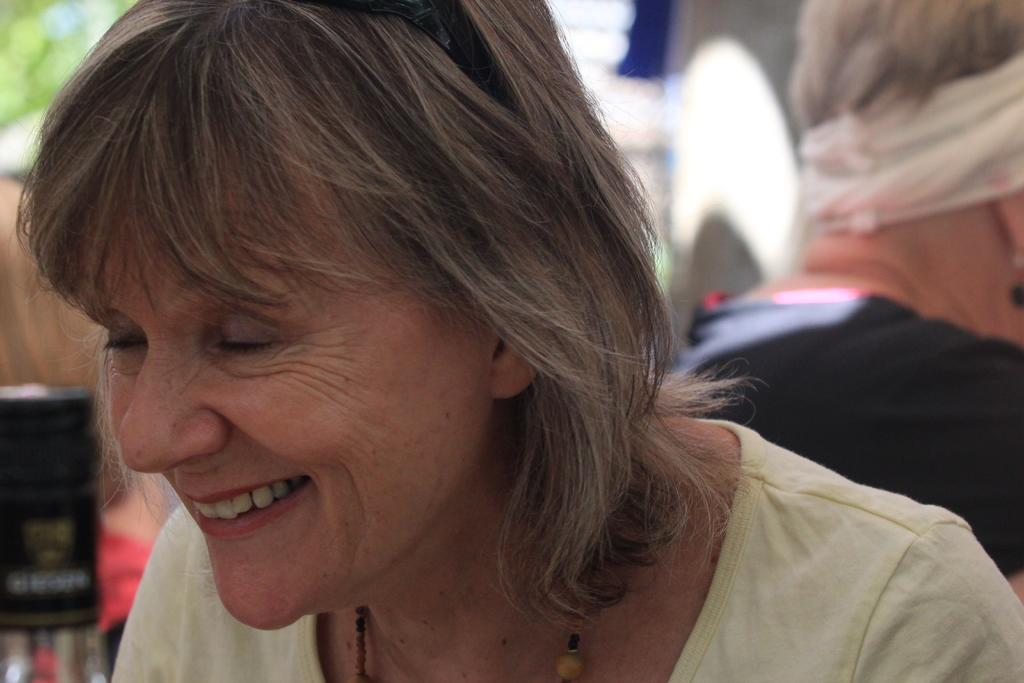How many people are in the image? There are two persons in the image. What else can be seen in the image besides the people? There are objects, a tree, and a building in the image. Can you describe the setting of the image? The image was likely taken during the day, as there is a tree and a building visible. What type of suit is the tree wearing in the image? There is no suit present in the image, as the tree is a plant and not a person. 